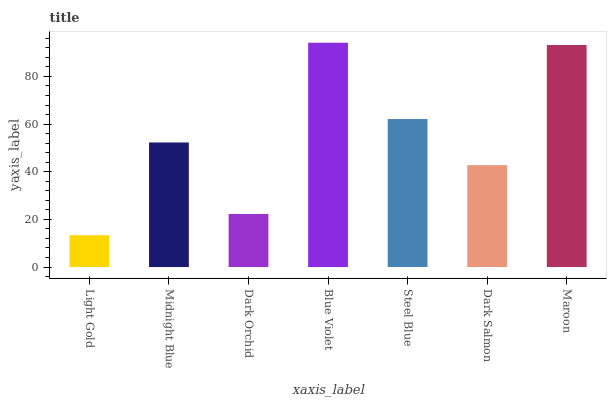Is Light Gold the minimum?
Answer yes or no. Yes. Is Blue Violet the maximum?
Answer yes or no. Yes. Is Midnight Blue the minimum?
Answer yes or no. No. Is Midnight Blue the maximum?
Answer yes or no. No. Is Midnight Blue greater than Light Gold?
Answer yes or no. Yes. Is Light Gold less than Midnight Blue?
Answer yes or no. Yes. Is Light Gold greater than Midnight Blue?
Answer yes or no. No. Is Midnight Blue less than Light Gold?
Answer yes or no. No. Is Midnight Blue the high median?
Answer yes or no. Yes. Is Midnight Blue the low median?
Answer yes or no. Yes. Is Dark Salmon the high median?
Answer yes or no. No. Is Light Gold the low median?
Answer yes or no. No. 